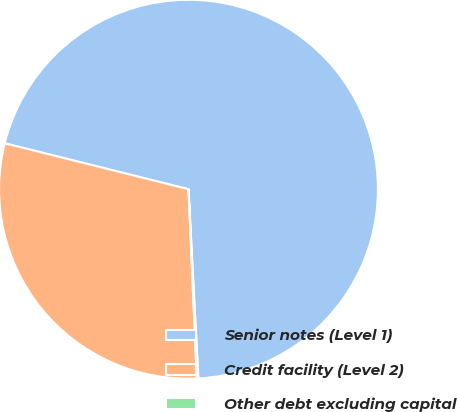<chart> <loc_0><loc_0><loc_500><loc_500><pie_chart><fcel>Senior notes (Level 1)<fcel>Credit facility (Level 2)<fcel>Other debt excluding capital<nl><fcel>70.28%<fcel>29.6%<fcel>0.13%<nl></chart> 